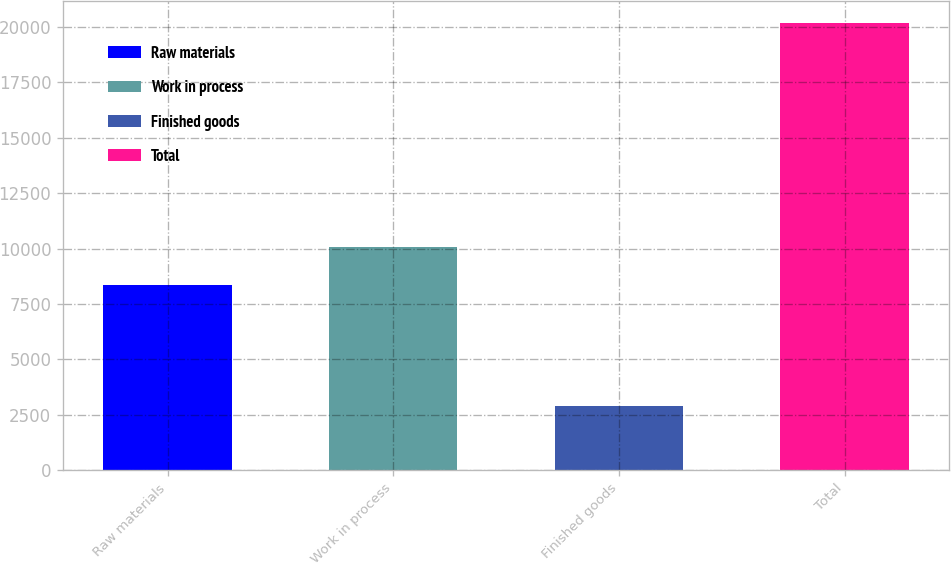Convert chart. <chart><loc_0><loc_0><loc_500><loc_500><bar_chart><fcel>Raw materials<fcel>Work in process<fcel>Finished goods<fcel>Total<nl><fcel>8365<fcel>10092.2<fcel>2897<fcel>20169<nl></chart> 